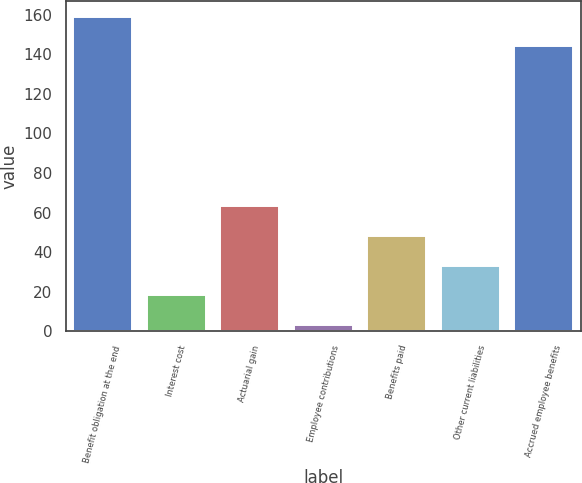Convert chart to OTSL. <chart><loc_0><loc_0><loc_500><loc_500><bar_chart><fcel>Benefit obligation at the end<fcel>Interest cost<fcel>Actuarial gain<fcel>Employee contributions<fcel>Benefits paid<fcel>Other current liabilities<fcel>Accrued employee benefits<nl><fcel>159.1<fcel>18.1<fcel>63.4<fcel>3<fcel>48.3<fcel>33.2<fcel>144<nl></chart> 